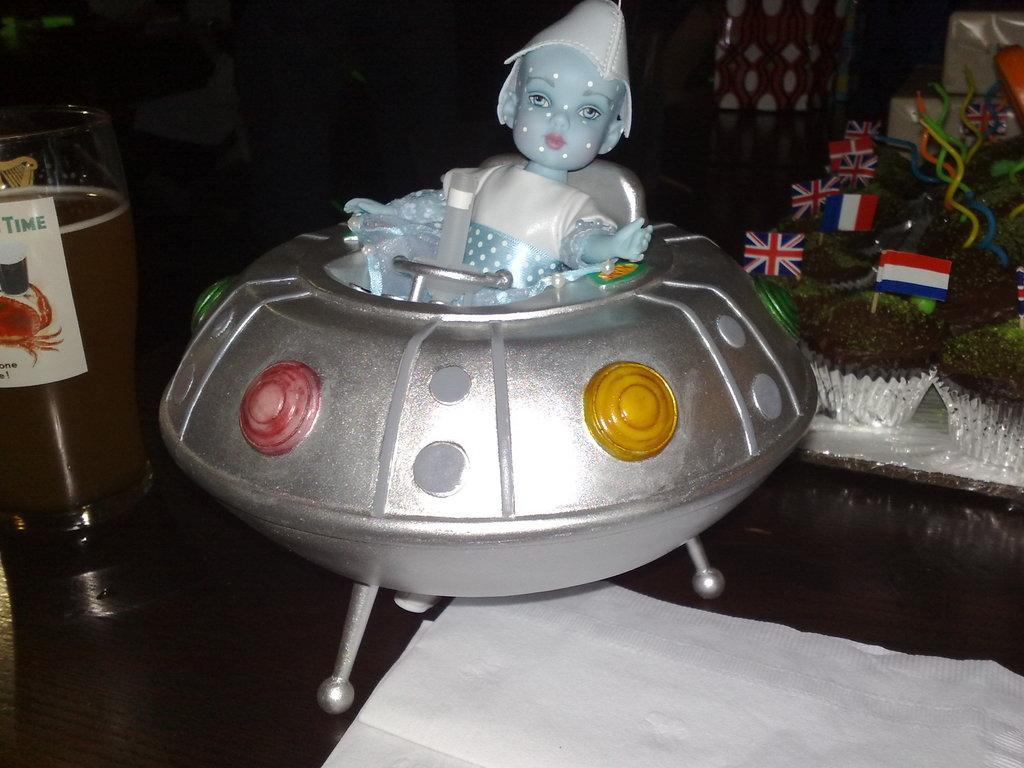In one or two sentences, can you explain what this image depicts? In this image, we can see some objects like a toy, a paper and a glass with some liquid. We can also see some objects on the right. We can see some flags. 